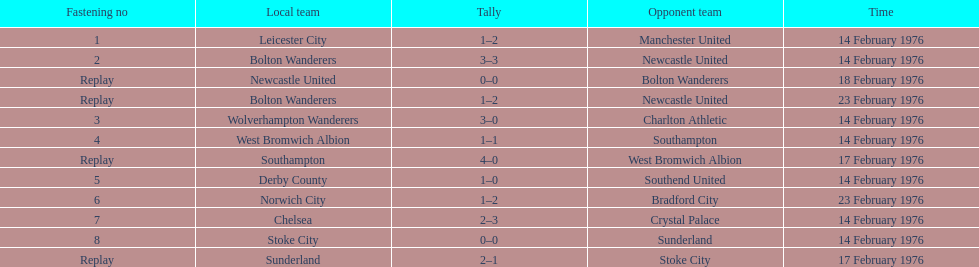How many games played by sunderland are listed here? 2. 